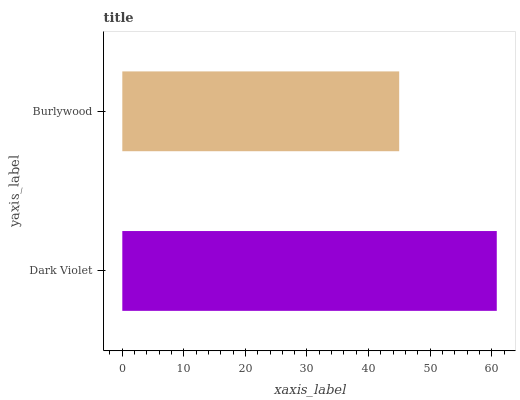Is Burlywood the minimum?
Answer yes or no. Yes. Is Dark Violet the maximum?
Answer yes or no. Yes. Is Burlywood the maximum?
Answer yes or no. No. Is Dark Violet greater than Burlywood?
Answer yes or no. Yes. Is Burlywood less than Dark Violet?
Answer yes or no. Yes. Is Burlywood greater than Dark Violet?
Answer yes or no. No. Is Dark Violet less than Burlywood?
Answer yes or no. No. Is Dark Violet the high median?
Answer yes or no. Yes. Is Burlywood the low median?
Answer yes or no. Yes. Is Burlywood the high median?
Answer yes or no. No. Is Dark Violet the low median?
Answer yes or no. No. 